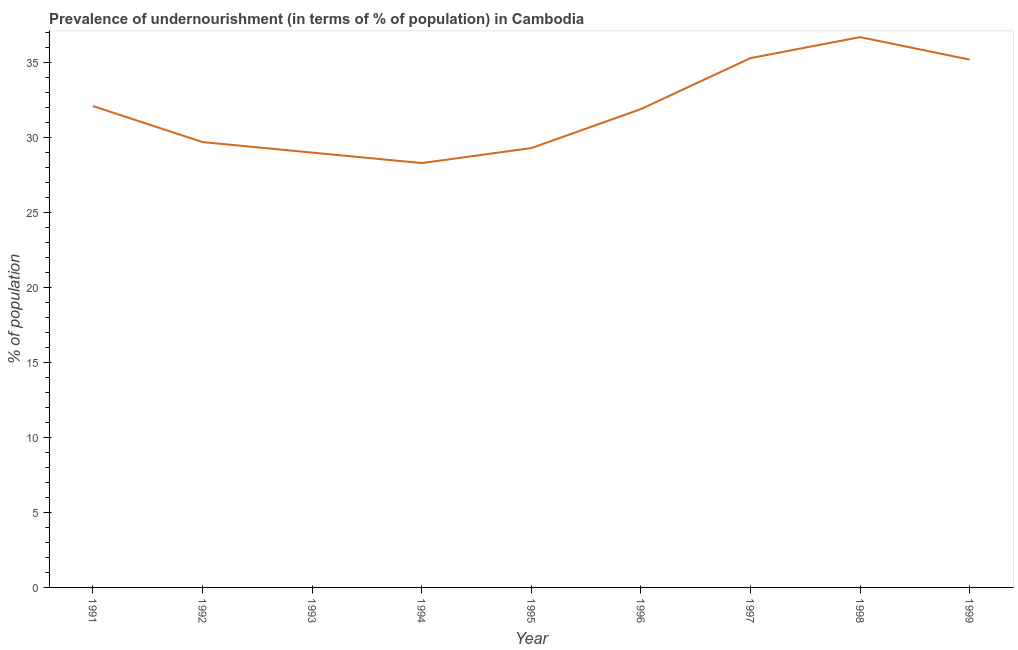What is the percentage of undernourished population in 1993?
Your answer should be compact. 29. Across all years, what is the maximum percentage of undernourished population?
Give a very brief answer. 36.7. Across all years, what is the minimum percentage of undernourished population?
Provide a short and direct response. 28.3. In which year was the percentage of undernourished population minimum?
Provide a succinct answer. 1994. What is the sum of the percentage of undernourished population?
Your answer should be very brief. 287.5. What is the average percentage of undernourished population per year?
Your response must be concise. 31.94. What is the median percentage of undernourished population?
Offer a terse response. 31.9. In how many years, is the percentage of undernourished population greater than 31 %?
Keep it short and to the point. 5. What is the ratio of the percentage of undernourished population in 1992 to that in 1996?
Keep it short and to the point. 0.93. What is the difference between the highest and the second highest percentage of undernourished population?
Your answer should be very brief. 1.4. What is the difference between the highest and the lowest percentage of undernourished population?
Provide a succinct answer. 8.4. Does the percentage of undernourished population monotonically increase over the years?
Your response must be concise. No. How many lines are there?
Your response must be concise. 1. How many years are there in the graph?
Your answer should be compact. 9. What is the difference between two consecutive major ticks on the Y-axis?
Your response must be concise. 5. Are the values on the major ticks of Y-axis written in scientific E-notation?
Provide a succinct answer. No. Does the graph contain any zero values?
Provide a succinct answer. No. What is the title of the graph?
Ensure brevity in your answer.  Prevalence of undernourishment (in terms of % of population) in Cambodia. What is the label or title of the X-axis?
Your response must be concise. Year. What is the label or title of the Y-axis?
Provide a succinct answer. % of population. What is the % of population of 1991?
Your answer should be compact. 32.1. What is the % of population of 1992?
Offer a very short reply. 29.7. What is the % of population in 1994?
Ensure brevity in your answer.  28.3. What is the % of population of 1995?
Your response must be concise. 29.3. What is the % of population in 1996?
Give a very brief answer. 31.9. What is the % of population of 1997?
Keep it short and to the point. 35.3. What is the % of population of 1998?
Your answer should be compact. 36.7. What is the % of population in 1999?
Make the answer very short. 35.2. What is the difference between the % of population in 1991 and 1993?
Offer a terse response. 3.1. What is the difference between the % of population in 1991 and 1994?
Your response must be concise. 3.8. What is the difference between the % of population in 1992 and 1993?
Keep it short and to the point. 0.7. What is the difference between the % of population in 1992 and 1994?
Your answer should be compact. 1.4. What is the difference between the % of population in 1992 and 1995?
Offer a very short reply. 0.4. What is the difference between the % of population in 1993 and 1995?
Keep it short and to the point. -0.3. What is the difference between the % of population in 1993 and 1996?
Your response must be concise. -2.9. What is the difference between the % of population in 1993 and 1997?
Ensure brevity in your answer.  -6.3. What is the difference between the % of population in 1994 and 1998?
Offer a very short reply. -8.4. What is the difference between the % of population in 1995 and 1999?
Offer a very short reply. -5.9. What is the difference between the % of population in 1996 and 1998?
Your answer should be very brief. -4.8. What is the difference between the % of population in 1997 and 1999?
Provide a succinct answer. 0.1. What is the ratio of the % of population in 1991 to that in 1992?
Your answer should be very brief. 1.08. What is the ratio of the % of population in 1991 to that in 1993?
Make the answer very short. 1.11. What is the ratio of the % of population in 1991 to that in 1994?
Provide a succinct answer. 1.13. What is the ratio of the % of population in 1991 to that in 1995?
Your answer should be compact. 1.1. What is the ratio of the % of population in 1991 to that in 1997?
Make the answer very short. 0.91. What is the ratio of the % of population in 1991 to that in 1999?
Give a very brief answer. 0.91. What is the ratio of the % of population in 1992 to that in 1993?
Offer a very short reply. 1.02. What is the ratio of the % of population in 1992 to that in 1994?
Make the answer very short. 1.05. What is the ratio of the % of population in 1992 to that in 1995?
Give a very brief answer. 1.01. What is the ratio of the % of population in 1992 to that in 1997?
Provide a succinct answer. 0.84. What is the ratio of the % of population in 1992 to that in 1998?
Provide a succinct answer. 0.81. What is the ratio of the % of population in 1992 to that in 1999?
Make the answer very short. 0.84. What is the ratio of the % of population in 1993 to that in 1995?
Ensure brevity in your answer.  0.99. What is the ratio of the % of population in 1993 to that in 1996?
Make the answer very short. 0.91. What is the ratio of the % of population in 1993 to that in 1997?
Your response must be concise. 0.82. What is the ratio of the % of population in 1993 to that in 1998?
Offer a very short reply. 0.79. What is the ratio of the % of population in 1993 to that in 1999?
Offer a terse response. 0.82. What is the ratio of the % of population in 1994 to that in 1995?
Your response must be concise. 0.97. What is the ratio of the % of population in 1994 to that in 1996?
Your answer should be very brief. 0.89. What is the ratio of the % of population in 1994 to that in 1997?
Give a very brief answer. 0.8. What is the ratio of the % of population in 1994 to that in 1998?
Keep it short and to the point. 0.77. What is the ratio of the % of population in 1994 to that in 1999?
Offer a terse response. 0.8. What is the ratio of the % of population in 1995 to that in 1996?
Offer a terse response. 0.92. What is the ratio of the % of population in 1995 to that in 1997?
Provide a short and direct response. 0.83. What is the ratio of the % of population in 1995 to that in 1998?
Ensure brevity in your answer.  0.8. What is the ratio of the % of population in 1995 to that in 1999?
Give a very brief answer. 0.83. What is the ratio of the % of population in 1996 to that in 1997?
Your answer should be compact. 0.9. What is the ratio of the % of population in 1996 to that in 1998?
Make the answer very short. 0.87. What is the ratio of the % of population in 1996 to that in 1999?
Make the answer very short. 0.91. What is the ratio of the % of population in 1997 to that in 1999?
Give a very brief answer. 1. What is the ratio of the % of population in 1998 to that in 1999?
Offer a very short reply. 1.04. 